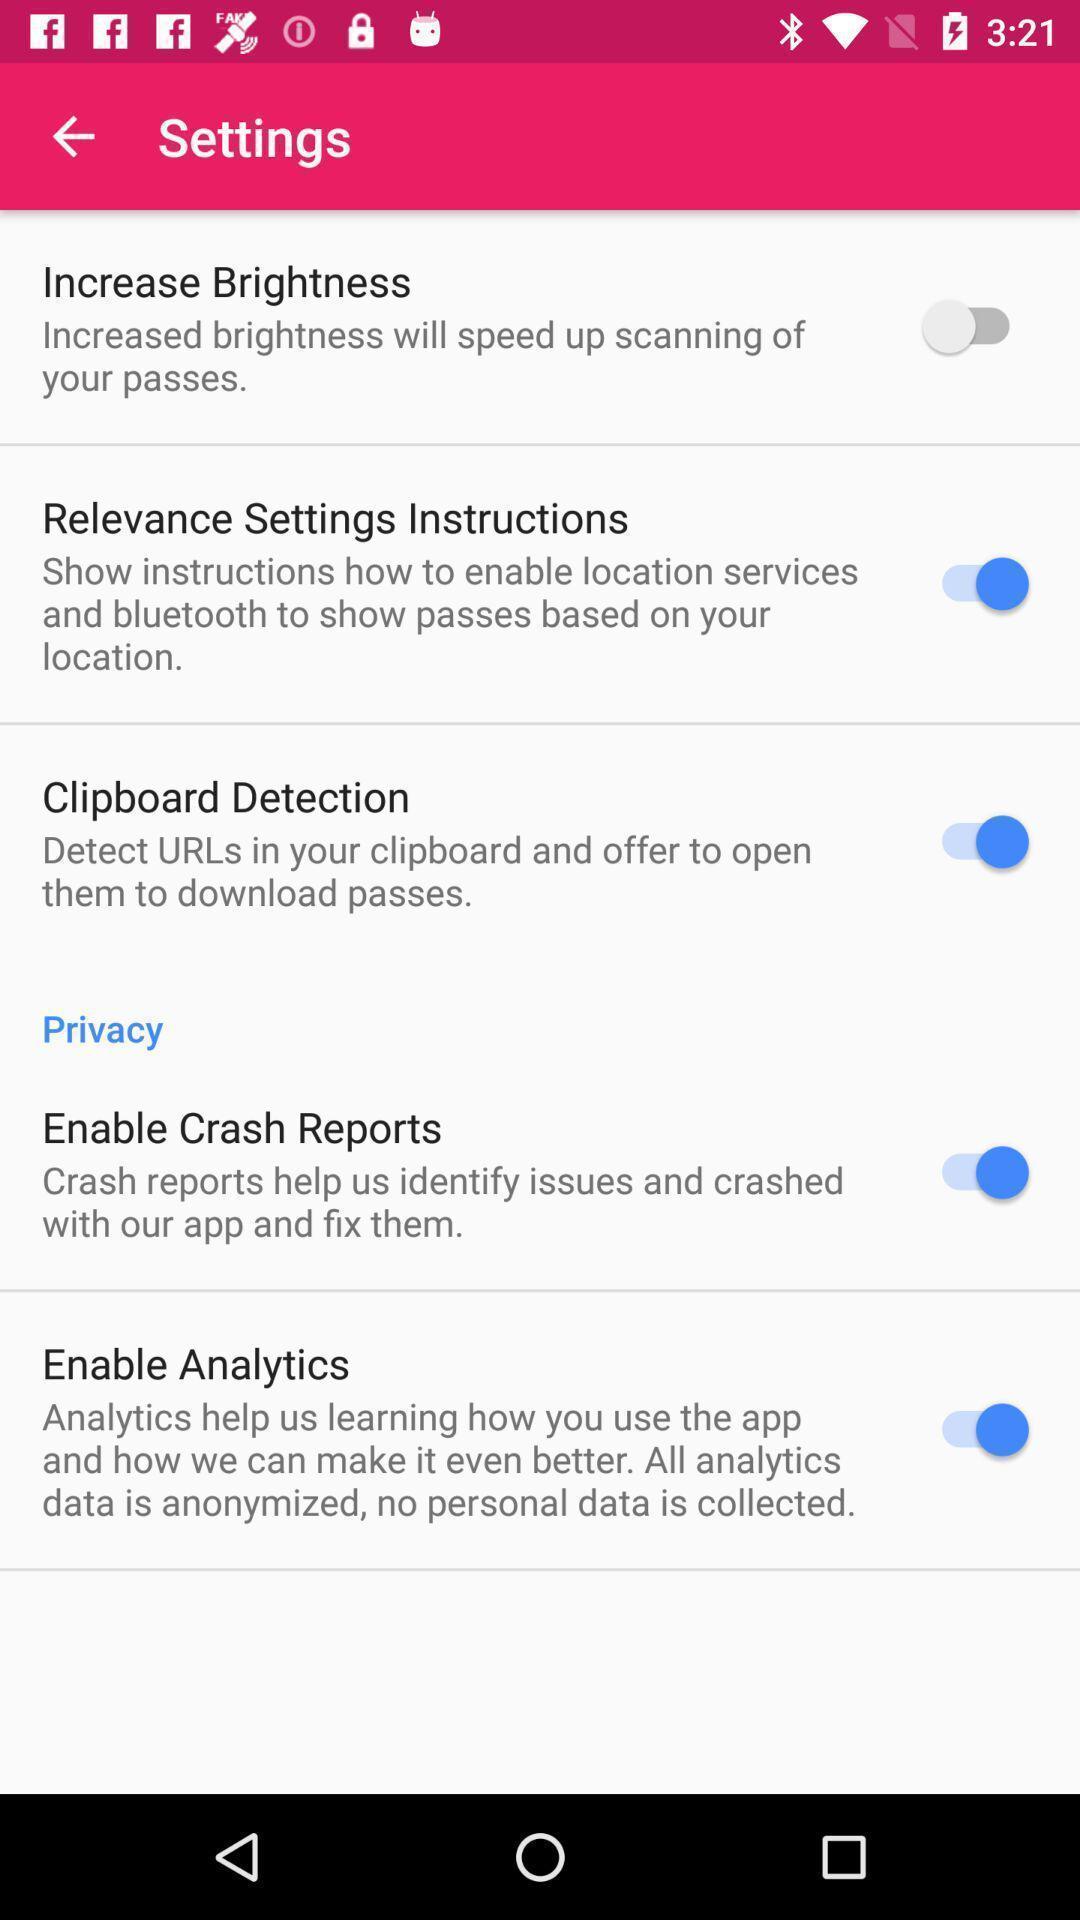Please provide a description for this image. Settings page. 